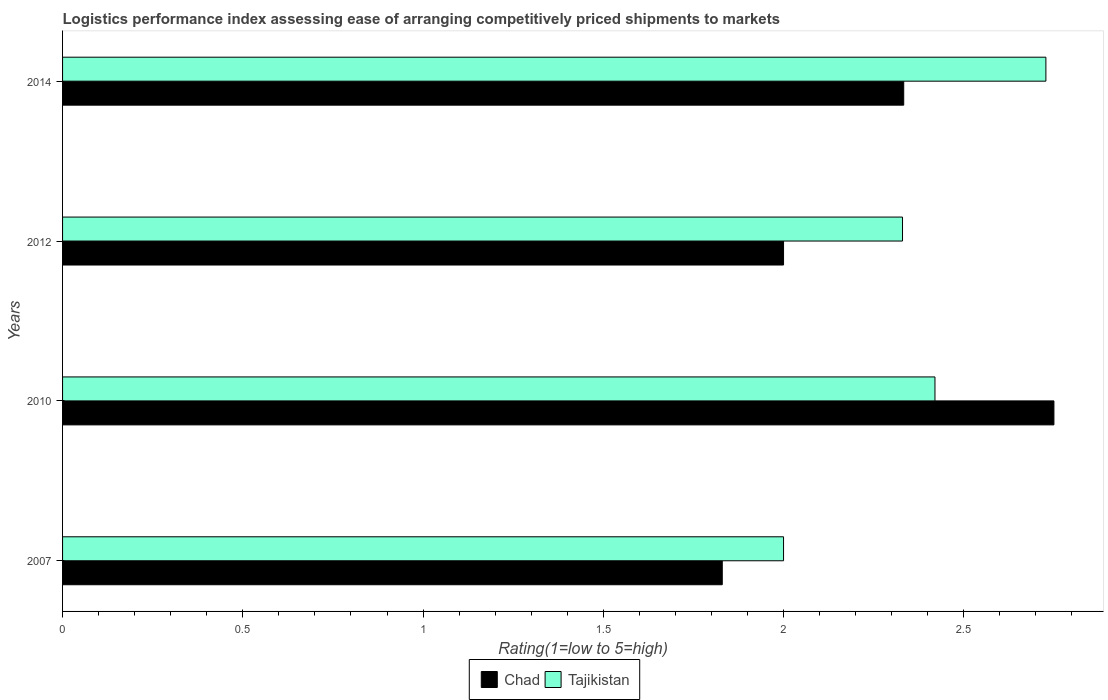Are the number of bars on each tick of the Y-axis equal?
Your answer should be compact. Yes. What is the label of the 3rd group of bars from the top?
Offer a terse response. 2010. In how many cases, is the number of bars for a given year not equal to the number of legend labels?
Offer a very short reply. 0. What is the Logistic performance index in Chad in 2010?
Your answer should be compact. 2.75. Across all years, what is the maximum Logistic performance index in Tajikistan?
Offer a very short reply. 2.73. Across all years, what is the minimum Logistic performance index in Chad?
Provide a succinct answer. 1.83. In which year was the Logistic performance index in Chad minimum?
Keep it short and to the point. 2007. What is the total Logistic performance index in Chad in the graph?
Your answer should be compact. 8.91. What is the difference between the Logistic performance index in Chad in 2012 and that in 2014?
Keep it short and to the point. -0.33. What is the difference between the Logistic performance index in Tajikistan in 2007 and the Logistic performance index in Chad in 2012?
Provide a short and direct response. 0. What is the average Logistic performance index in Chad per year?
Provide a short and direct response. 2.23. In the year 2007, what is the difference between the Logistic performance index in Chad and Logistic performance index in Tajikistan?
Your response must be concise. -0.17. What is the ratio of the Logistic performance index in Tajikistan in 2007 to that in 2012?
Offer a terse response. 0.86. Is the Logistic performance index in Tajikistan in 2007 less than that in 2012?
Offer a terse response. Yes. Is the difference between the Logistic performance index in Chad in 2012 and 2014 greater than the difference between the Logistic performance index in Tajikistan in 2012 and 2014?
Give a very brief answer. Yes. What is the difference between the highest and the second highest Logistic performance index in Tajikistan?
Keep it short and to the point. 0.31. What is the difference between the highest and the lowest Logistic performance index in Tajikistan?
Provide a succinct answer. 0.73. What does the 1st bar from the top in 2010 represents?
Offer a very short reply. Tajikistan. What does the 2nd bar from the bottom in 2012 represents?
Your answer should be very brief. Tajikistan. How many years are there in the graph?
Provide a succinct answer. 4. What is the difference between two consecutive major ticks on the X-axis?
Your answer should be very brief. 0.5. Are the values on the major ticks of X-axis written in scientific E-notation?
Offer a very short reply. No. Where does the legend appear in the graph?
Make the answer very short. Bottom center. What is the title of the graph?
Provide a short and direct response. Logistics performance index assessing ease of arranging competitively priced shipments to markets. Does "Gambia, The" appear as one of the legend labels in the graph?
Your response must be concise. No. What is the label or title of the X-axis?
Provide a short and direct response. Rating(1=low to 5=high). What is the Rating(1=low to 5=high) in Chad in 2007?
Ensure brevity in your answer.  1.83. What is the Rating(1=low to 5=high) in Chad in 2010?
Offer a very short reply. 2.75. What is the Rating(1=low to 5=high) of Tajikistan in 2010?
Make the answer very short. 2.42. What is the Rating(1=low to 5=high) in Tajikistan in 2012?
Your response must be concise. 2.33. What is the Rating(1=low to 5=high) in Chad in 2014?
Your answer should be compact. 2.33. What is the Rating(1=low to 5=high) in Tajikistan in 2014?
Your response must be concise. 2.73. Across all years, what is the maximum Rating(1=low to 5=high) in Chad?
Your answer should be very brief. 2.75. Across all years, what is the maximum Rating(1=low to 5=high) in Tajikistan?
Keep it short and to the point. 2.73. Across all years, what is the minimum Rating(1=low to 5=high) of Chad?
Ensure brevity in your answer.  1.83. What is the total Rating(1=low to 5=high) in Chad in the graph?
Offer a terse response. 8.91. What is the total Rating(1=low to 5=high) in Tajikistan in the graph?
Provide a short and direct response. 9.48. What is the difference between the Rating(1=low to 5=high) in Chad in 2007 and that in 2010?
Provide a succinct answer. -0.92. What is the difference between the Rating(1=low to 5=high) in Tajikistan in 2007 and that in 2010?
Give a very brief answer. -0.42. What is the difference between the Rating(1=low to 5=high) in Chad in 2007 and that in 2012?
Offer a very short reply. -0.17. What is the difference between the Rating(1=low to 5=high) of Tajikistan in 2007 and that in 2012?
Provide a short and direct response. -0.33. What is the difference between the Rating(1=low to 5=high) in Chad in 2007 and that in 2014?
Offer a terse response. -0.5. What is the difference between the Rating(1=low to 5=high) in Tajikistan in 2007 and that in 2014?
Your answer should be very brief. -0.73. What is the difference between the Rating(1=low to 5=high) in Tajikistan in 2010 and that in 2012?
Keep it short and to the point. 0.09. What is the difference between the Rating(1=low to 5=high) in Chad in 2010 and that in 2014?
Keep it short and to the point. 0.42. What is the difference between the Rating(1=low to 5=high) of Tajikistan in 2010 and that in 2014?
Offer a very short reply. -0.31. What is the difference between the Rating(1=low to 5=high) of Tajikistan in 2012 and that in 2014?
Provide a succinct answer. -0.4. What is the difference between the Rating(1=low to 5=high) in Chad in 2007 and the Rating(1=low to 5=high) in Tajikistan in 2010?
Ensure brevity in your answer.  -0.59. What is the difference between the Rating(1=low to 5=high) in Chad in 2007 and the Rating(1=low to 5=high) in Tajikistan in 2012?
Your answer should be very brief. -0.5. What is the difference between the Rating(1=low to 5=high) of Chad in 2007 and the Rating(1=low to 5=high) of Tajikistan in 2014?
Your response must be concise. -0.9. What is the difference between the Rating(1=low to 5=high) in Chad in 2010 and the Rating(1=low to 5=high) in Tajikistan in 2012?
Your answer should be compact. 0.42. What is the difference between the Rating(1=low to 5=high) in Chad in 2010 and the Rating(1=low to 5=high) in Tajikistan in 2014?
Give a very brief answer. 0.02. What is the difference between the Rating(1=low to 5=high) of Chad in 2012 and the Rating(1=low to 5=high) of Tajikistan in 2014?
Ensure brevity in your answer.  -0.73. What is the average Rating(1=low to 5=high) of Chad per year?
Provide a short and direct response. 2.23. What is the average Rating(1=low to 5=high) in Tajikistan per year?
Make the answer very short. 2.37. In the year 2007, what is the difference between the Rating(1=low to 5=high) of Chad and Rating(1=low to 5=high) of Tajikistan?
Your response must be concise. -0.17. In the year 2010, what is the difference between the Rating(1=low to 5=high) in Chad and Rating(1=low to 5=high) in Tajikistan?
Offer a terse response. 0.33. In the year 2012, what is the difference between the Rating(1=low to 5=high) in Chad and Rating(1=low to 5=high) in Tajikistan?
Keep it short and to the point. -0.33. In the year 2014, what is the difference between the Rating(1=low to 5=high) in Chad and Rating(1=low to 5=high) in Tajikistan?
Keep it short and to the point. -0.39. What is the ratio of the Rating(1=low to 5=high) in Chad in 2007 to that in 2010?
Provide a short and direct response. 0.67. What is the ratio of the Rating(1=low to 5=high) in Tajikistan in 2007 to that in 2010?
Offer a very short reply. 0.83. What is the ratio of the Rating(1=low to 5=high) in Chad in 2007 to that in 2012?
Your answer should be compact. 0.92. What is the ratio of the Rating(1=low to 5=high) in Tajikistan in 2007 to that in 2012?
Offer a terse response. 0.86. What is the ratio of the Rating(1=low to 5=high) in Chad in 2007 to that in 2014?
Ensure brevity in your answer.  0.78. What is the ratio of the Rating(1=low to 5=high) in Tajikistan in 2007 to that in 2014?
Ensure brevity in your answer.  0.73. What is the ratio of the Rating(1=low to 5=high) of Chad in 2010 to that in 2012?
Provide a short and direct response. 1.38. What is the ratio of the Rating(1=low to 5=high) of Tajikistan in 2010 to that in 2012?
Offer a very short reply. 1.04. What is the ratio of the Rating(1=low to 5=high) in Chad in 2010 to that in 2014?
Keep it short and to the point. 1.18. What is the ratio of the Rating(1=low to 5=high) of Tajikistan in 2010 to that in 2014?
Your answer should be compact. 0.89. What is the ratio of the Rating(1=low to 5=high) in Chad in 2012 to that in 2014?
Ensure brevity in your answer.  0.86. What is the ratio of the Rating(1=low to 5=high) in Tajikistan in 2012 to that in 2014?
Make the answer very short. 0.85. What is the difference between the highest and the second highest Rating(1=low to 5=high) of Chad?
Your answer should be compact. 0.42. What is the difference between the highest and the second highest Rating(1=low to 5=high) of Tajikistan?
Your answer should be very brief. 0.31. What is the difference between the highest and the lowest Rating(1=low to 5=high) of Chad?
Your answer should be very brief. 0.92. What is the difference between the highest and the lowest Rating(1=low to 5=high) of Tajikistan?
Make the answer very short. 0.73. 